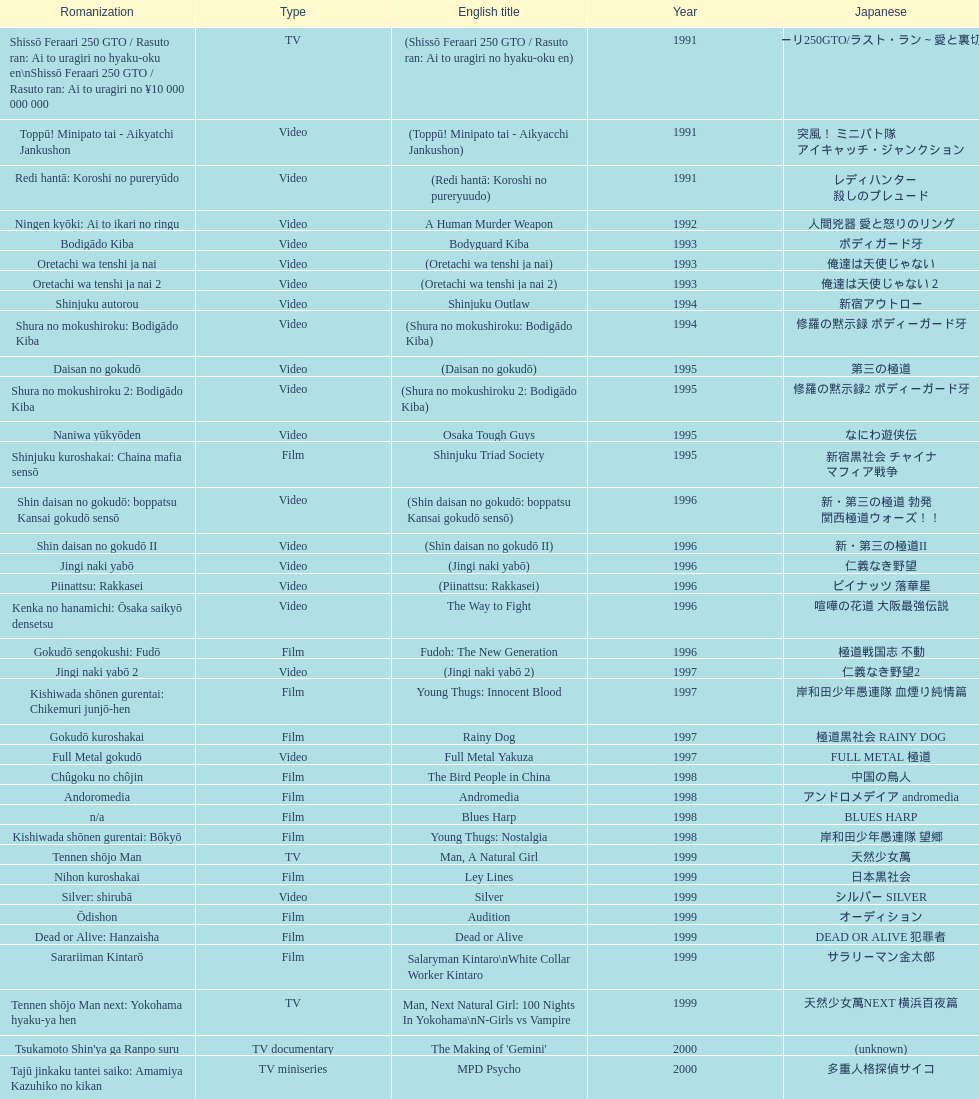Were more air on tv or video? Video. 